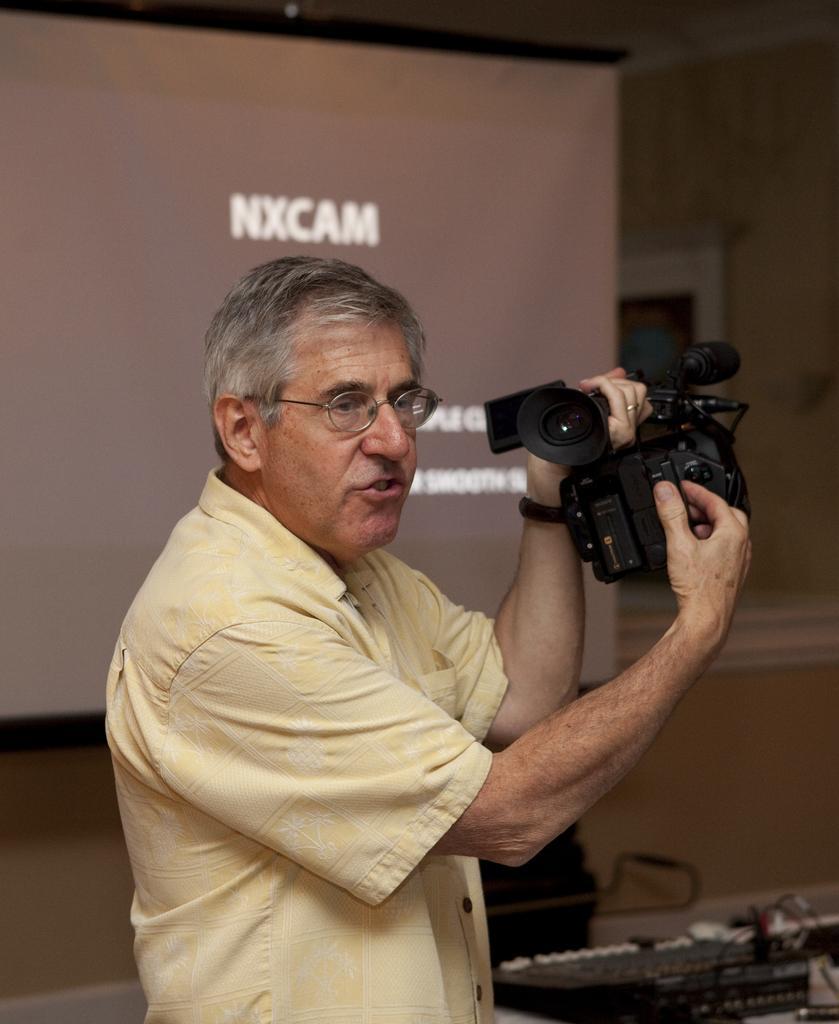Please provide a concise description of this image. In the center of the image there is a person wearing a yellow color shirt and he is holding a video recorder in his hand. In the background of the image there is a projector screen. There is a wall. 